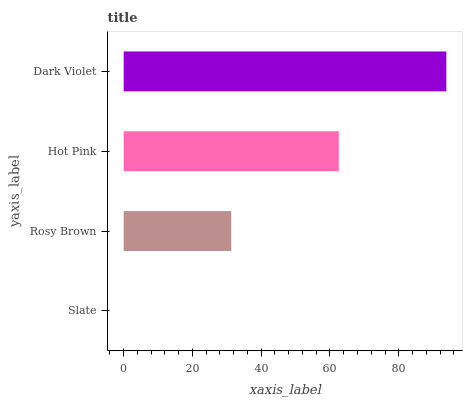Is Slate the minimum?
Answer yes or no. Yes. Is Dark Violet the maximum?
Answer yes or no. Yes. Is Rosy Brown the minimum?
Answer yes or no. No. Is Rosy Brown the maximum?
Answer yes or no. No. Is Rosy Brown greater than Slate?
Answer yes or no. Yes. Is Slate less than Rosy Brown?
Answer yes or no. Yes. Is Slate greater than Rosy Brown?
Answer yes or no. No. Is Rosy Brown less than Slate?
Answer yes or no. No. Is Hot Pink the high median?
Answer yes or no. Yes. Is Rosy Brown the low median?
Answer yes or no. Yes. Is Dark Violet the high median?
Answer yes or no. No. Is Dark Violet the low median?
Answer yes or no. No. 